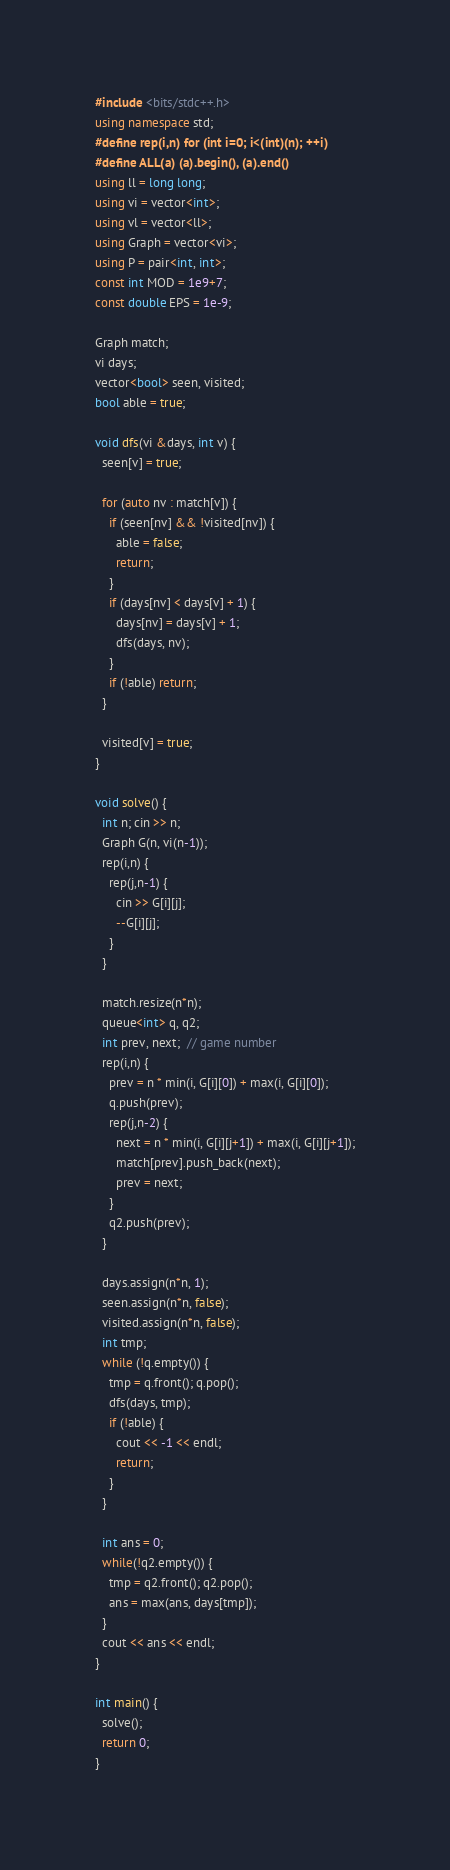<code> <loc_0><loc_0><loc_500><loc_500><_C++_>#include <bits/stdc++.h>
using namespace std;
#define rep(i,n) for (int i=0; i<(int)(n); ++i)
#define ALL(a) (a).begin(), (a).end()
using ll = long long;
using vi = vector<int>;
using vl = vector<ll>;
using Graph = vector<vi>;
using P = pair<int, int>;
const int MOD = 1e9+7;
const double EPS = 1e-9;

Graph match;
vi days;
vector<bool> seen, visited;
bool able = true;

void dfs(vi &days, int v) {
  seen[v] = true;

  for (auto nv : match[v]) {
    if (seen[nv] && !visited[nv]) {
      able = false;
      return;
    }
    if (days[nv] < days[v] + 1) {
      days[nv] = days[v] + 1;
      dfs(days, nv);
    }
    if (!able) return;
  }

  visited[v] = true;
}

void solve() {
  int n; cin >> n;
  Graph G(n, vi(n-1));
  rep(i,n) {
    rep(j,n-1) {
      cin >> G[i][j];
      --G[i][j];
    }
  }

  match.resize(n*n);
  queue<int> q, q2;
  int prev, next;  // game number
  rep(i,n) {
    prev = n * min(i, G[i][0]) + max(i, G[i][0]);
    q.push(prev);
    rep(j,n-2) {
      next = n * min(i, G[i][j+1]) + max(i, G[i][j+1]);
      match[prev].push_back(next);
      prev = next;
    }
    q2.push(prev);
  }

  days.assign(n*n, 1);
  seen.assign(n*n, false);
  visited.assign(n*n, false);
  int tmp;
  while (!q.empty()) {
    tmp = q.front(); q.pop();
    dfs(days, tmp);
    if (!able) {
      cout << -1 << endl;
      return;
    }
  }

  int ans = 0;
  while(!q2.empty()) {
    tmp = q2.front(); q2.pop();
    ans = max(ans, days[tmp]);
  }
  cout << ans << endl;
}

int main() {
  solve();
  return 0;
}
</code> 